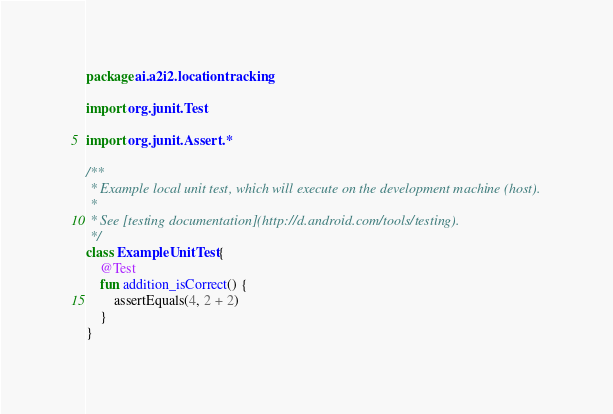<code> <loc_0><loc_0><loc_500><loc_500><_Kotlin_>package ai.a2i2.locationtracking

import org.junit.Test

import org.junit.Assert.*

/**
 * Example local unit test, which will execute on the development machine (host).
 *
 * See [testing documentation](http://d.android.com/tools/testing).
 */
class ExampleUnitTest {
    @Test
    fun addition_isCorrect() {
        assertEquals(4, 2 + 2)
    }
}</code> 